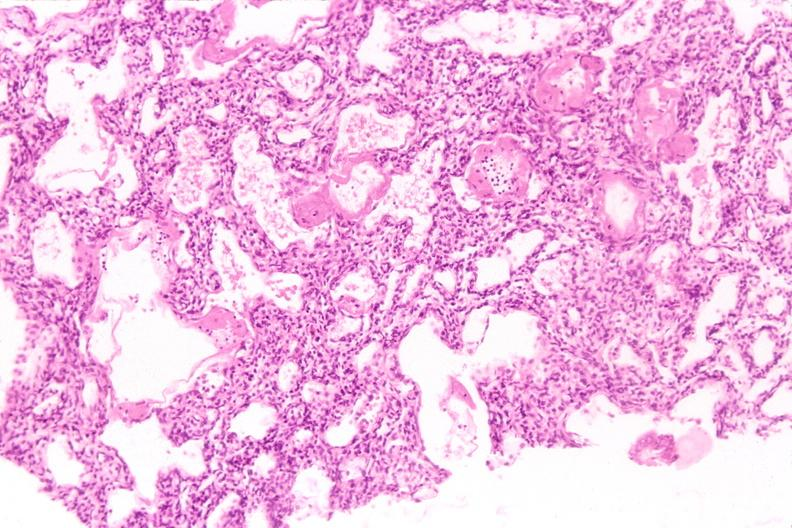does this image show lungs, hyaline membrane disease?
Answer the question using a single word or phrase. Yes 